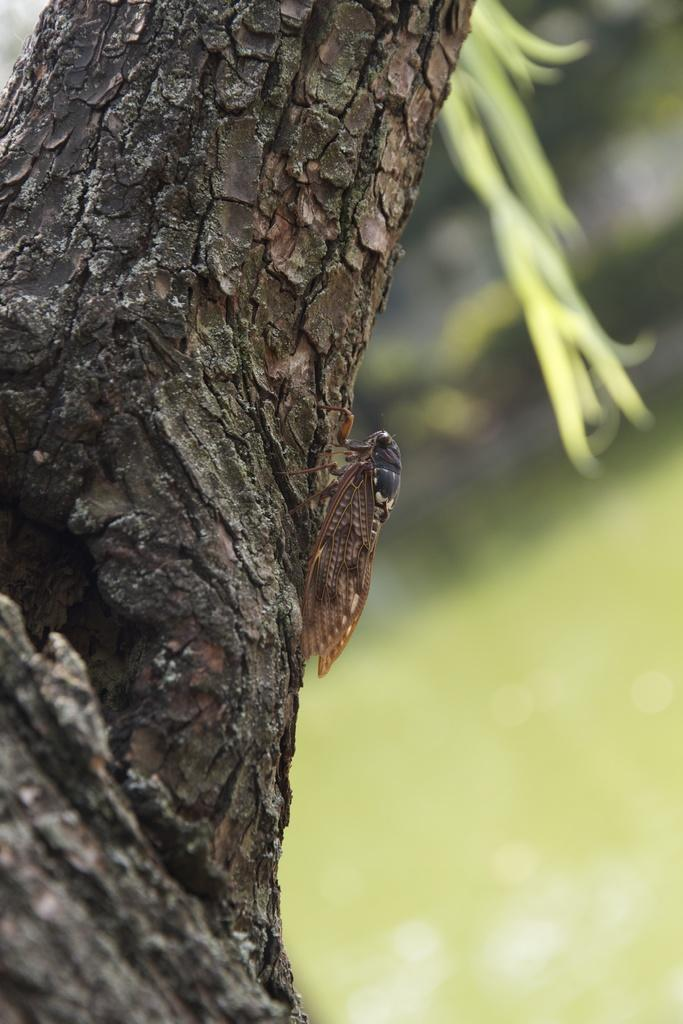What is located on the tree in the image? There is an insect on a tree in the image. What can be seen in the background of the image? There are plants and grass in the background of the image. What is the ground like in the image? The ground is visible in the background of the image. What type of bells can be heard ringing in the image? There are no bells present in the image, and therefore no sound can be heard. 